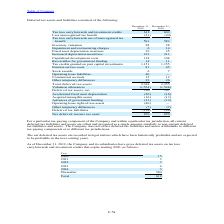According to Stmicroelectronics's financial document, What was the tax loss carryforwards and investment credits in 2019? According to the financial document, 612. The relevant text states: "Tax loss carryforwards and investment credits 612 603..." Also, What adjustments are made by the company for deferred tax asset and liabilities? The Company does not offset deferred tax liabilities and assets attributable to different tax-paying components or to different tax jurisdictions.. The document states: "o non-current deferred tax liabilities and assets. The Company does not offset deferred tax liabilities and assets attributable to different tax-payin..." Also, What was the inventory valuation in 2019? According to the financial document, 28. The relevant text states: "Inventory valuation 28 28..." Also, can you calculate: What is the increase/ (decrease) in Total deferred tax assets from December 31, 2018 to 2019? Based on the calculation: 2,324-2,255, the result is 69. This is based on the information: "Total deferred tax assets 2,324 2,255 Total deferred tax assets 2,324 2,255..." The key data points involved are: 2,255, 2,324. Also, can you calculate: What is the increase/ (decrease) in Deferred tax liabilities from December 31, 2018 to 2019? Based on the calculation: 114-48, the result is 66. This is based on the information: "Deferred tax liabilities (114) (48) Deferred tax liabilities (114) (48)..." The key data points involved are: 114, 48. Also, can you calculate: What is the increase/ (decrease) in Net deferred income tax asset from December 31, 2018 to 2019? Based on the calculation: 676-659, the result is 17. This is based on the information: "Net deferred income tax asset 676 659 Net deferred income tax asset 676 659..." The key data points involved are: 659, 676. 